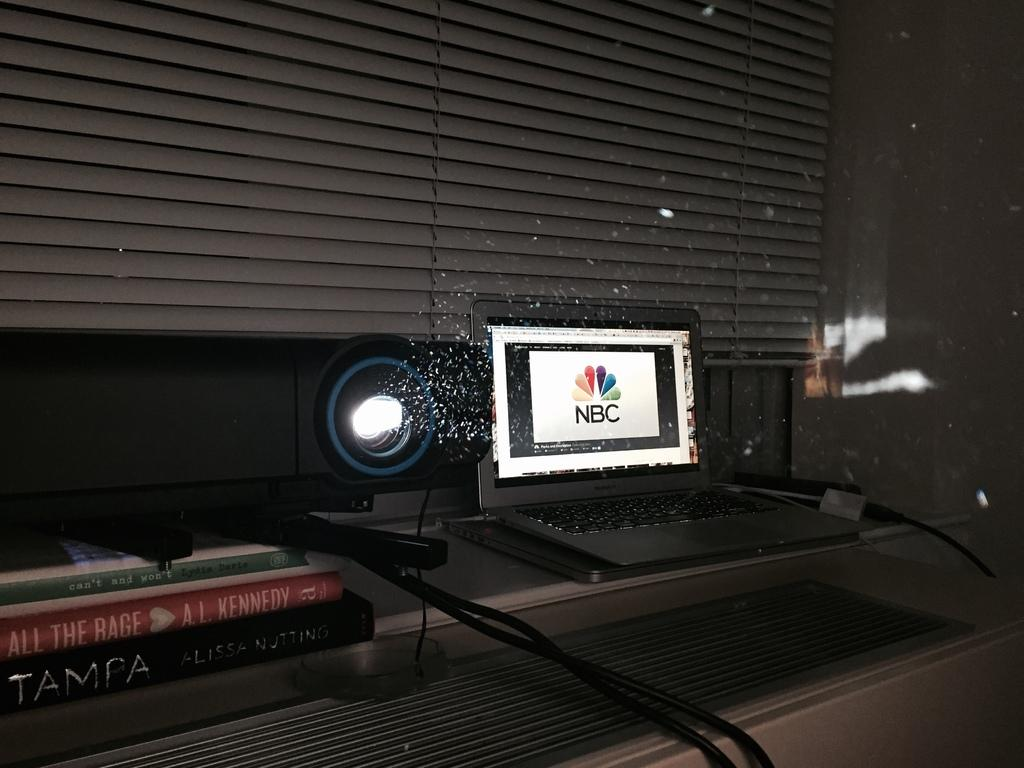<image>
Describe the image concisely. NBC showing on a computer monitor in a room. 